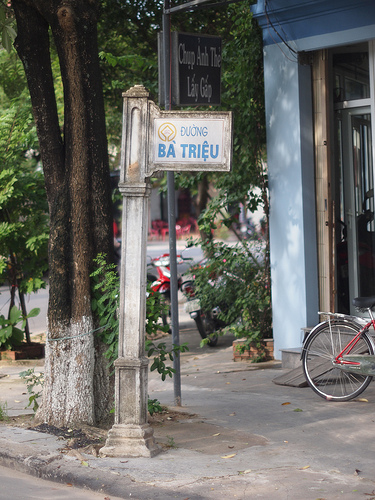Please provide the bounding box coordinate of the region this sentence describes: the tire is black. The coordinates for the bounding box around the region where 'the tire is black' are approximately [0.69, 0.62, 0.87, 0.81]. 